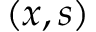Convert formula to latex. <formula><loc_0><loc_0><loc_500><loc_500>( x , s )</formula> 